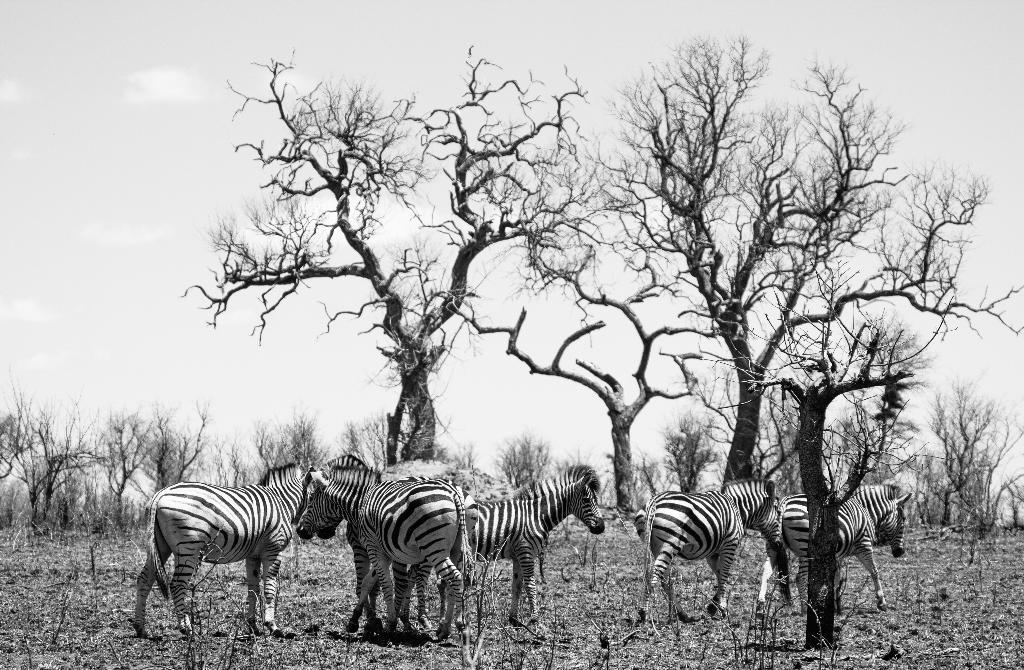What is the color scheme of the image? The image is black and white. What animals can be seen in the image? There are zebras in the image. What type of vegetation is present in the image? There are trees in the image. What can be seen in the background of the image? The sky is visible in the background of the image. What type of nerve is visible in the image? There is no nerve visible in the image; it features zebras and trees in a black and white setting. Can you tell me where the playground is located in the image? There is no playground present in the image; it features zebras and trees in a black and white setting. 